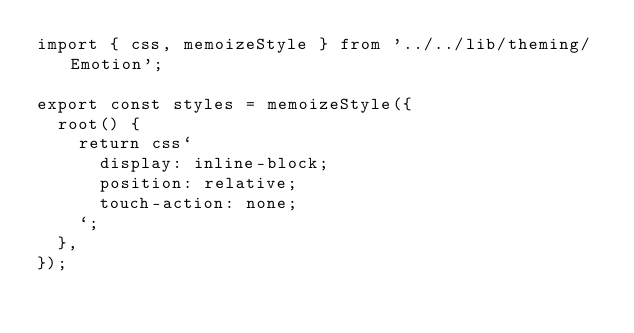<code> <loc_0><loc_0><loc_500><loc_500><_TypeScript_>import { css, memoizeStyle } from '../../lib/theming/Emotion';

export const styles = memoizeStyle({
  root() {
    return css`
      display: inline-block;
      position: relative;
      touch-action: none;
    `;
  },
});
</code> 